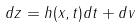Convert formula to latex. <formula><loc_0><loc_0><loc_500><loc_500>d z = h ( x , t ) d t + d v</formula> 